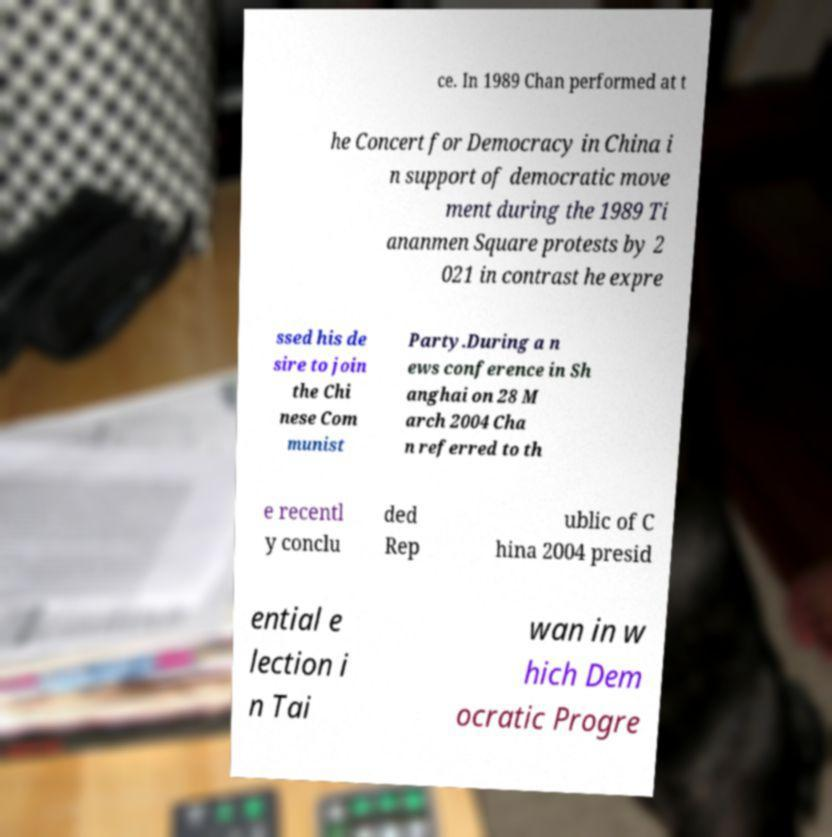Can you accurately transcribe the text from the provided image for me? ce. In 1989 Chan performed at t he Concert for Democracy in China i n support of democratic move ment during the 1989 Ti ananmen Square protests by 2 021 in contrast he expre ssed his de sire to join the Chi nese Com munist Party.During a n ews conference in Sh anghai on 28 M arch 2004 Cha n referred to th e recentl y conclu ded Rep ublic of C hina 2004 presid ential e lection i n Tai wan in w hich Dem ocratic Progre 